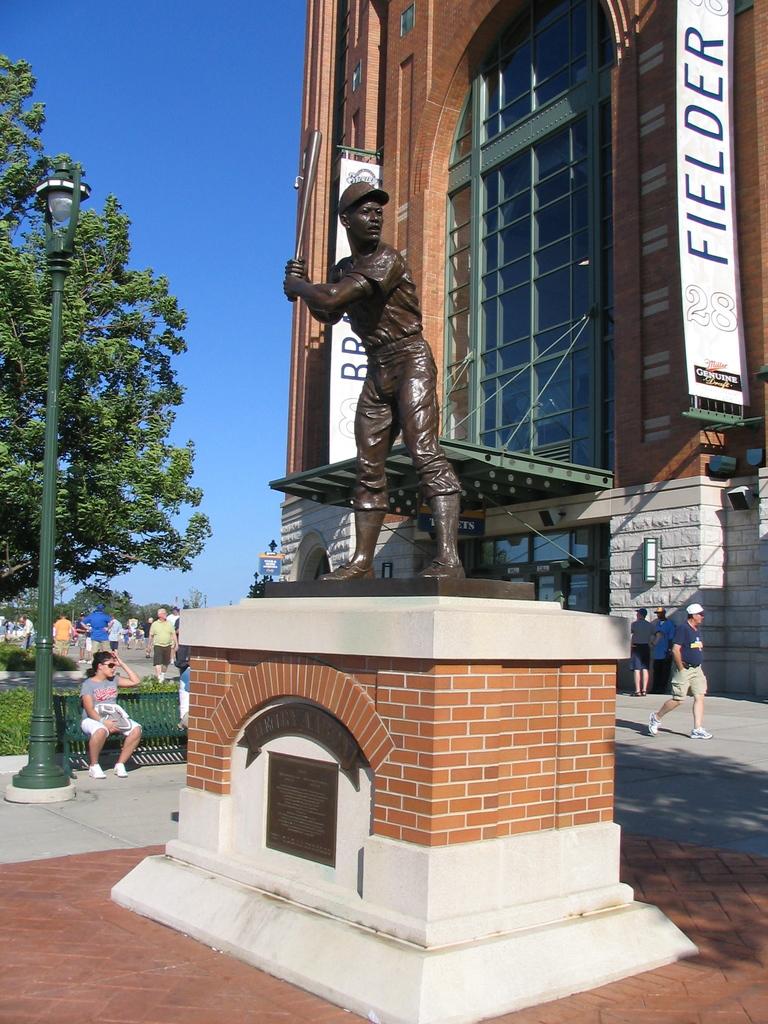What is in big letters on the white banner?
Make the answer very short. Fielder. 